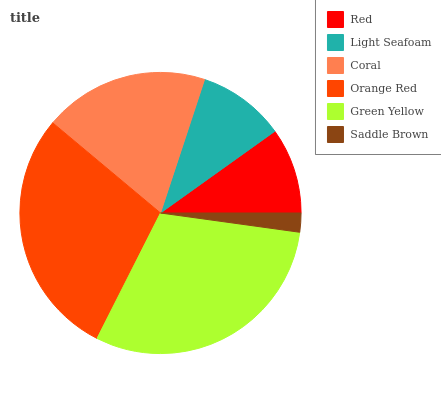Is Saddle Brown the minimum?
Answer yes or no. Yes. Is Green Yellow the maximum?
Answer yes or no. Yes. Is Light Seafoam the minimum?
Answer yes or no. No. Is Light Seafoam the maximum?
Answer yes or no. No. Is Light Seafoam greater than Red?
Answer yes or no. Yes. Is Red less than Light Seafoam?
Answer yes or no. Yes. Is Red greater than Light Seafoam?
Answer yes or no. No. Is Light Seafoam less than Red?
Answer yes or no. No. Is Coral the high median?
Answer yes or no. Yes. Is Light Seafoam the low median?
Answer yes or no. Yes. Is Red the high median?
Answer yes or no. No. Is Red the low median?
Answer yes or no. No. 